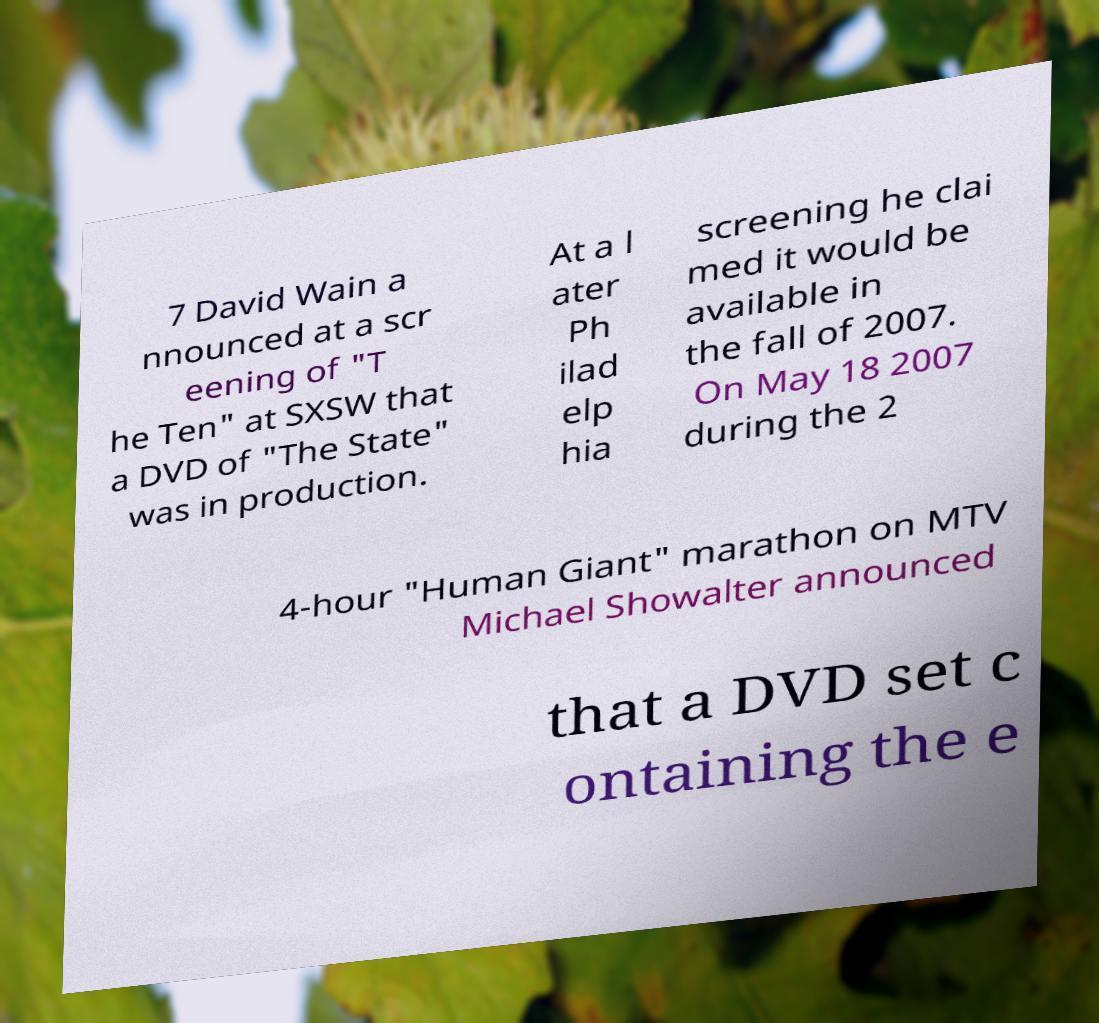Can you read and provide the text displayed in the image?This photo seems to have some interesting text. Can you extract and type it out for me? 7 David Wain a nnounced at a scr eening of "T he Ten" at SXSW that a DVD of "The State" was in production. At a l ater Ph ilad elp hia screening he clai med it would be available in the fall of 2007. On May 18 2007 during the 2 4-hour "Human Giant" marathon on MTV Michael Showalter announced that a DVD set c ontaining the e 